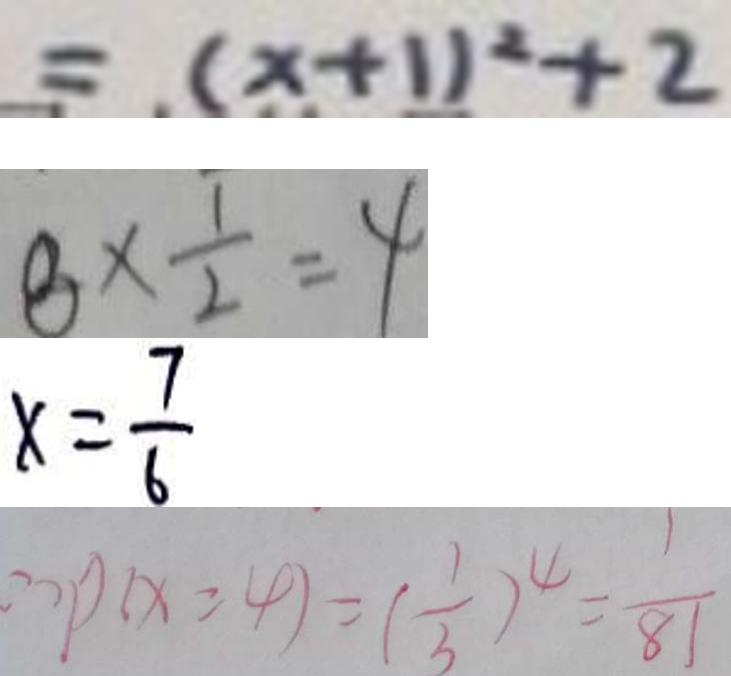Convert formula to latex. <formula><loc_0><loc_0><loc_500><loc_500>= ( x + 1 ) ^ { 2 } + 2 
 8 \times \frac { 1 } { 2 } = 4 
 x = \frac { 7 } { 6 } 
 \therefore p ( x = 4 ) = ( \frac { 1 } { 3 } ) ^ { 4 } = \frac { 1 } { 8 1 }</formula> 